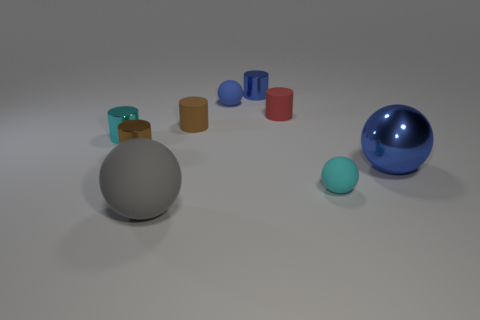Subtract 1 cylinders. How many cylinders are left? 4 Subtract all tiny cyan cylinders. How many cylinders are left? 4 Subtract all blue cylinders. How many cylinders are left? 4 Subtract all green spheres. Subtract all blue cylinders. How many spheres are left? 4 Add 1 big gray balls. How many objects exist? 10 Subtract all cylinders. How many objects are left? 4 Subtract 0 green blocks. How many objects are left? 9 Subtract all red metallic objects. Subtract all tiny spheres. How many objects are left? 7 Add 3 blue shiny balls. How many blue shiny balls are left? 4 Add 3 blue spheres. How many blue spheres exist? 5 